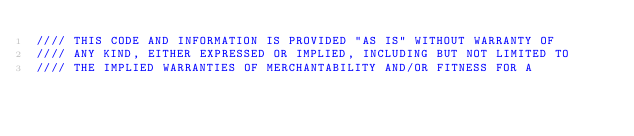Convert code to text. <code><loc_0><loc_0><loc_500><loc_500><_C++_>//// THIS CODE AND INFORMATION IS PROVIDED "AS IS" WITHOUT WARRANTY OF
//// ANY KIND, EITHER EXPRESSED OR IMPLIED, INCLUDING BUT NOT LIMITED TO
//// THE IMPLIED WARRANTIES OF MERCHANTABILITY AND/OR FITNESS FOR A</code> 